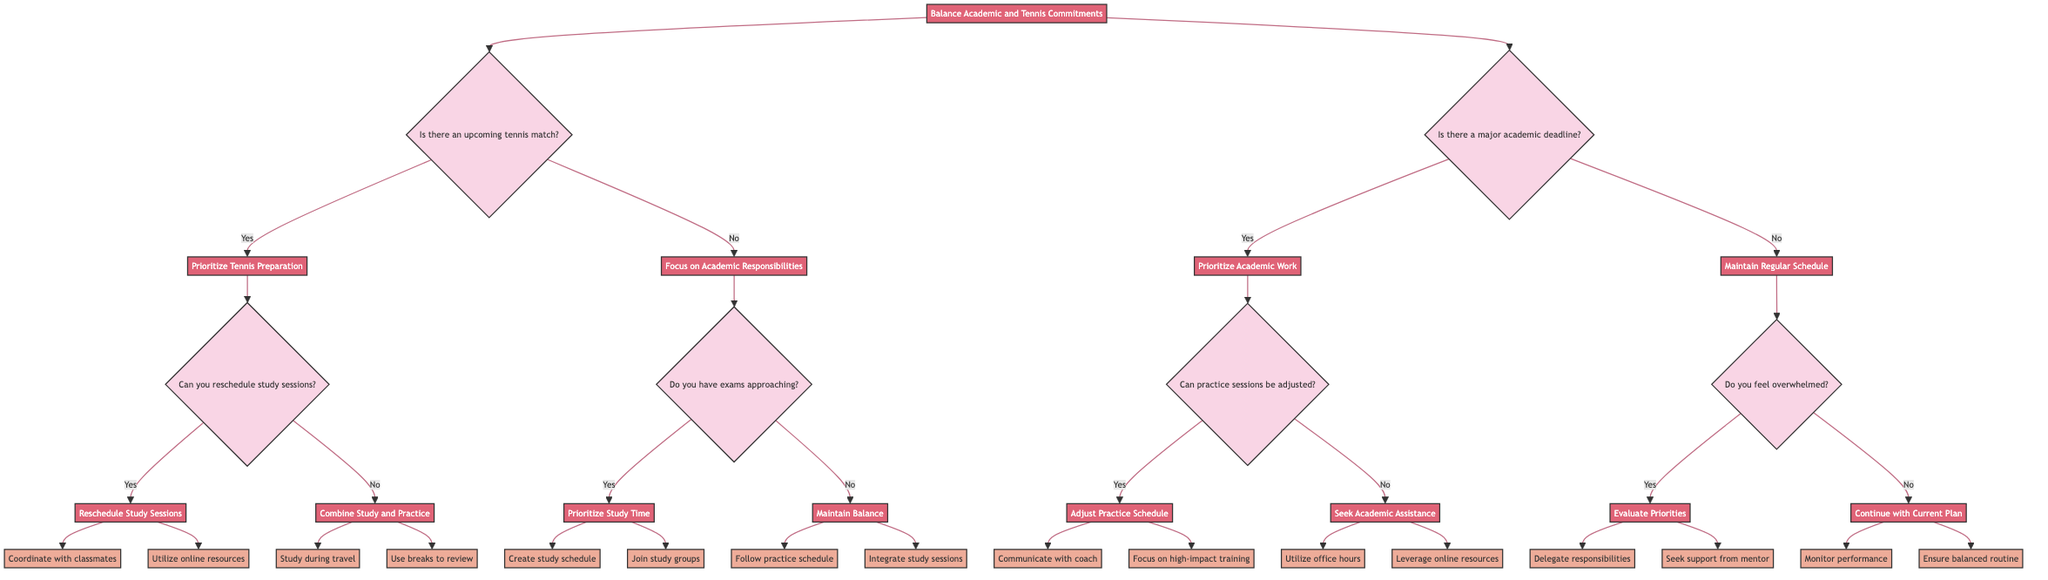What question follows if there is a major academic deadline? If the answer to "Is there a major academic deadline?" is yes, then the next question to ask is "Can practice sessions be adjusted?" This is clearly shown in the flowchart under the "Prioritize Academic Work" decision.
Answer: Can practice sessions be adjusted? What actions are suggested if study sessions can be rescheduled before a tennis match? If the ability to reschedule study sessions is confirmed (yes), the actions suggested are to "Coordinate with classmates for alternative study times" and "Utilize online resources and recorded lectures." This is derived from the "Reschedule Study Sessions" node under "Prioritize Tennis Preparation."
Answer: Coordinate with classmates for alternative study times, utilize online resources and recorded lectures How many nodes are in the decision tree? To determine the number of nodes, count all unique decision points and action statements depicted in the diagram, which amounts to a total of 20 nodes.
Answer: 20 What does the decision tree recommend if you feel overwhelmed? If the answer to "Do you feel overwhelmed?" is yes, the recommendation is to "Evaluate Priorities," which would involve delegating responsibilities or seeking support. This process follows from the "Maintain Regular Schedule" path in the diagram.
Answer: Evaluate Priorities How does the decision tree address upcoming tennis matches? The decision tree prioritizes tennis preparation if an upcoming tennis match is identified, leading to a consideration of whether study sessions can be rescheduled. This comes from the branching in the decision tree focused on balancing tennis and academic commitments.
Answer: Prioritize Tennis Preparation What is the outcome if there are no upcoming tennis matches and no major academic deadlines? In this scenario, the outcome leads to the node "Maintain Regular Schedule," where it further checks if the individual feels overwhelmed. If no, it suggests continuing with the current plan. This is derived from the flow that branches from both "No" decisions.
Answer: Maintain Regular Schedule What actions should be taken if exams are approaching? If exams are approaching, the recommended actions are to "Create a detailed study schedule" and "Join study groups for collaboration." This flow follows from confirming that there are approaching exams under the "Focus on Academic Responsibilities" section.
Answer: Create a detailed study schedule, join study groups for collaboration What is the main focus when there is no major academic deadline? When there is no major deadline, the main focus switches to maintaining a "Regular Schedule," which ensures balance in both academic and tennis commitments. This is evident in the branch that follows the "No" response to the academic deadline.
Answer: Maintain Regular Schedule 